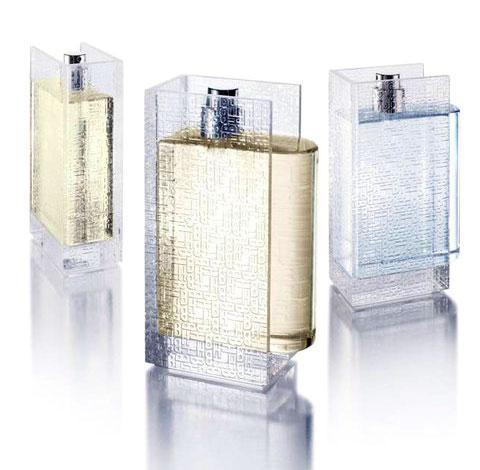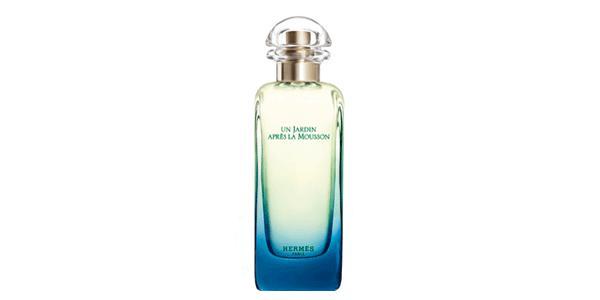The first image is the image on the left, the second image is the image on the right. Considering the images on both sides, is "There are at most two bottles of perfume." valid? Answer yes or no. No. 